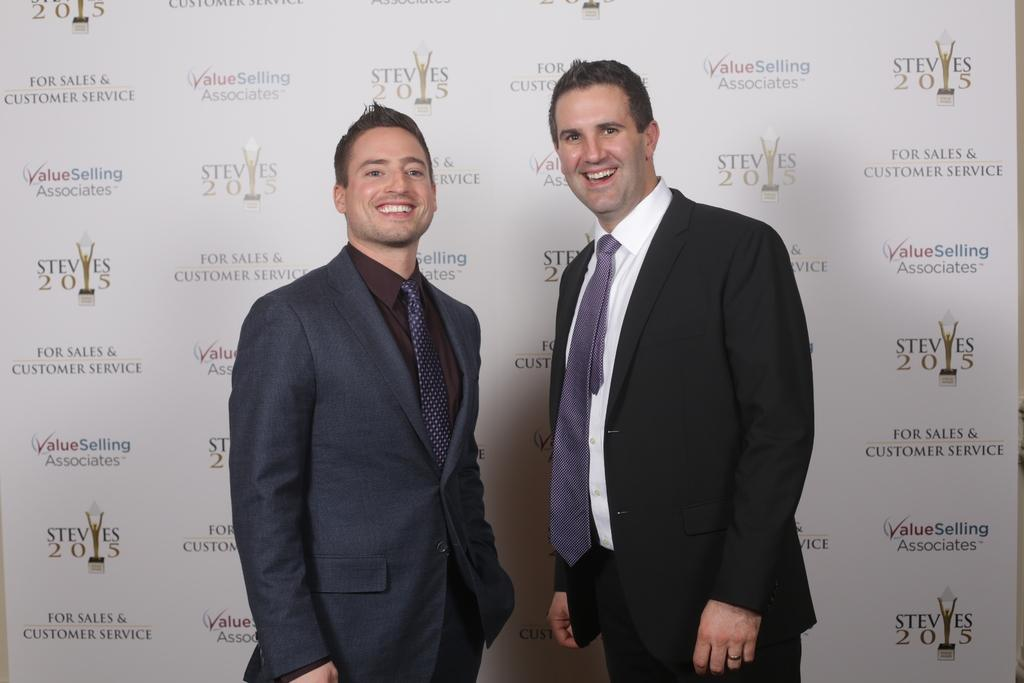How many people are in the image? There are two men in the image. What are the men doing in the image? The men are standing and laughing. What can be seen in the background of the image? There is a banner in the image. What is written on the banner? The banner has names of companies on it. Can you tell me which finger the man on the left is using to solve the riddle in the image? There is no riddle or finger-pointing activity present in the image; the men are simply standing and laughing. 